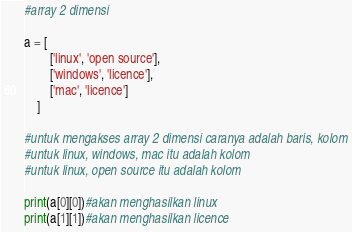<code> <loc_0><loc_0><loc_500><loc_500><_Python_>#array 2 dimensi

a = [
        ['linux', 'open source'],
        ['windows', 'licence'],
        ['mac', 'licence']
    ]

#untuk mengakses array 2 dimensi caranya adalah baris, kolom
#untuk linux, windows, mac itu adalah kolom
#untuk linux, open source itu adalah kolom

print(a[0][0])#akan menghasilkan linux
print(a[1][1])#akan menghasilkan licence
</code> 